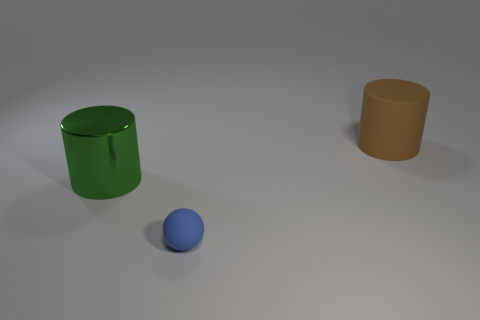Can you describe the lighting of this scene? Certainly. The scene is lit with a soft, diffused overhead light that casts gentle shadows directly beneath the objects, highlighting their volumes with subtlety and mitigating any harsh contrasts. 